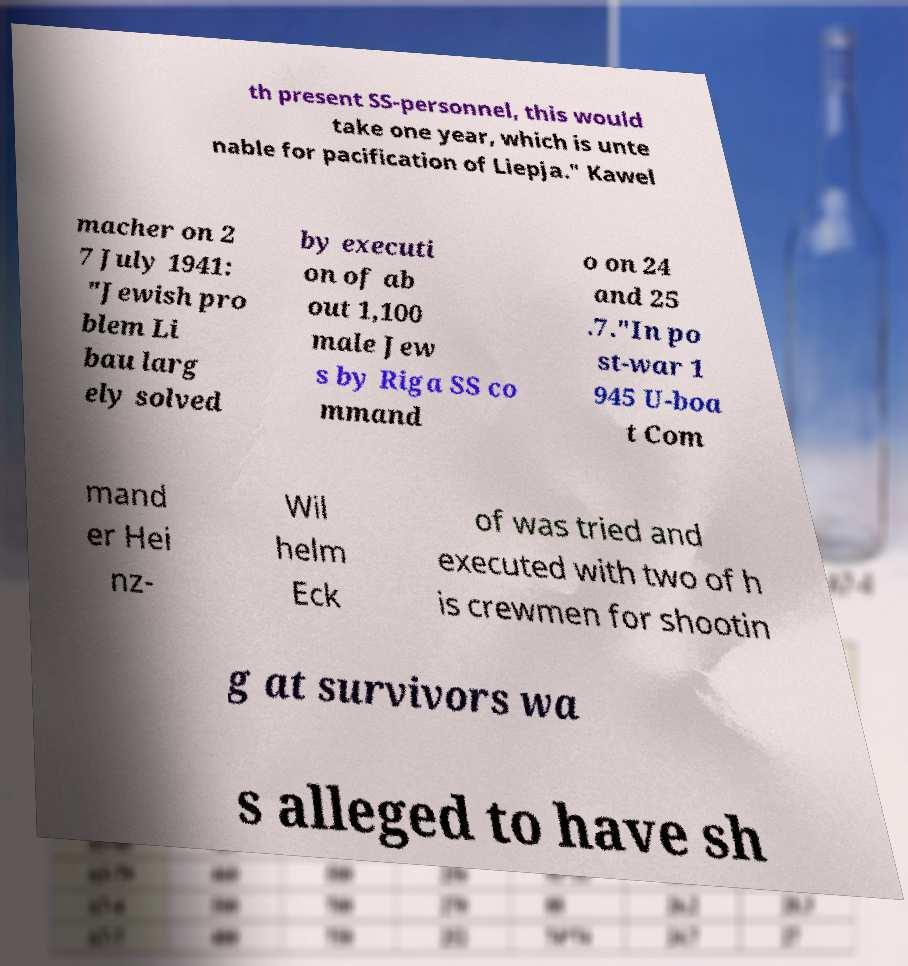Can you accurately transcribe the text from the provided image for me? th present SS-personnel, this would take one year, which is unte nable for pacification of Liepja." Kawel macher on 2 7 July 1941: "Jewish pro blem Li bau larg ely solved by executi on of ab out 1,100 male Jew s by Riga SS co mmand o on 24 and 25 .7."In po st-war 1 945 U-boa t Com mand er Hei nz- Wil helm Eck of was tried and executed with two of h is crewmen for shootin g at survivors wa s alleged to have sh 